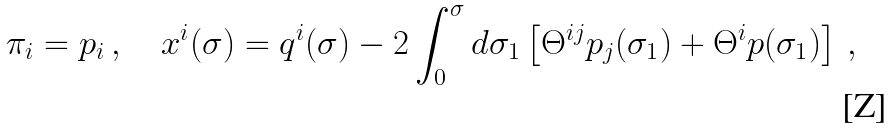Convert formula to latex. <formula><loc_0><loc_0><loc_500><loc_500>\pi _ { i } = p _ { i } \, , \quad x ^ { i } ( \sigma ) = q ^ { i } ( \sigma ) - 2 \int ^ { \sigma } _ { 0 } d \sigma _ { 1 } \left [ \Theta ^ { i j } p _ { j } ( \sigma _ { 1 } ) + \Theta ^ { i } p ( \sigma _ { 1 } ) \right ] \, ,</formula> 